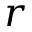Convert formula to latex. <formula><loc_0><loc_0><loc_500><loc_500>r</formula> 